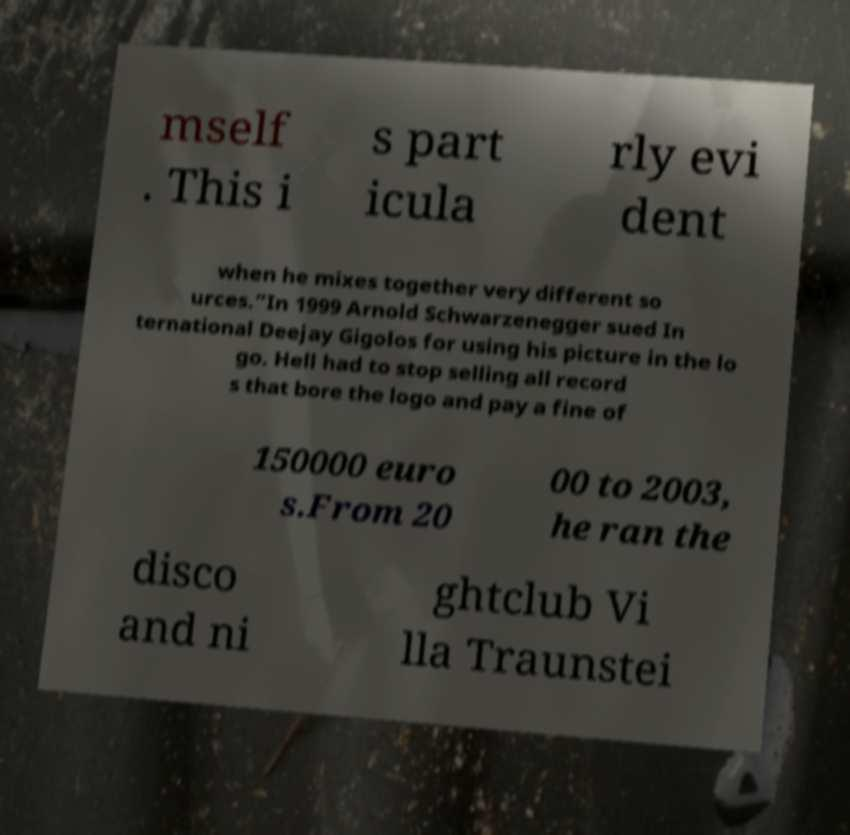There's text embedded in this image that I need extracted. Can you transcribe it verbatim? mself . This i s part icula rly evi dent when he mixes together very different so urces.”In 1999 Arnold Schwarzenegger sued In ternational Deejay Gigolos for using his picture in the lo go. Hell had to stop selling all record s that bore the logo and pay a fine of 150000 euro s.From 20 00 to 2003, he ran the disco and ni ghtclub Vi lla Traunstei 